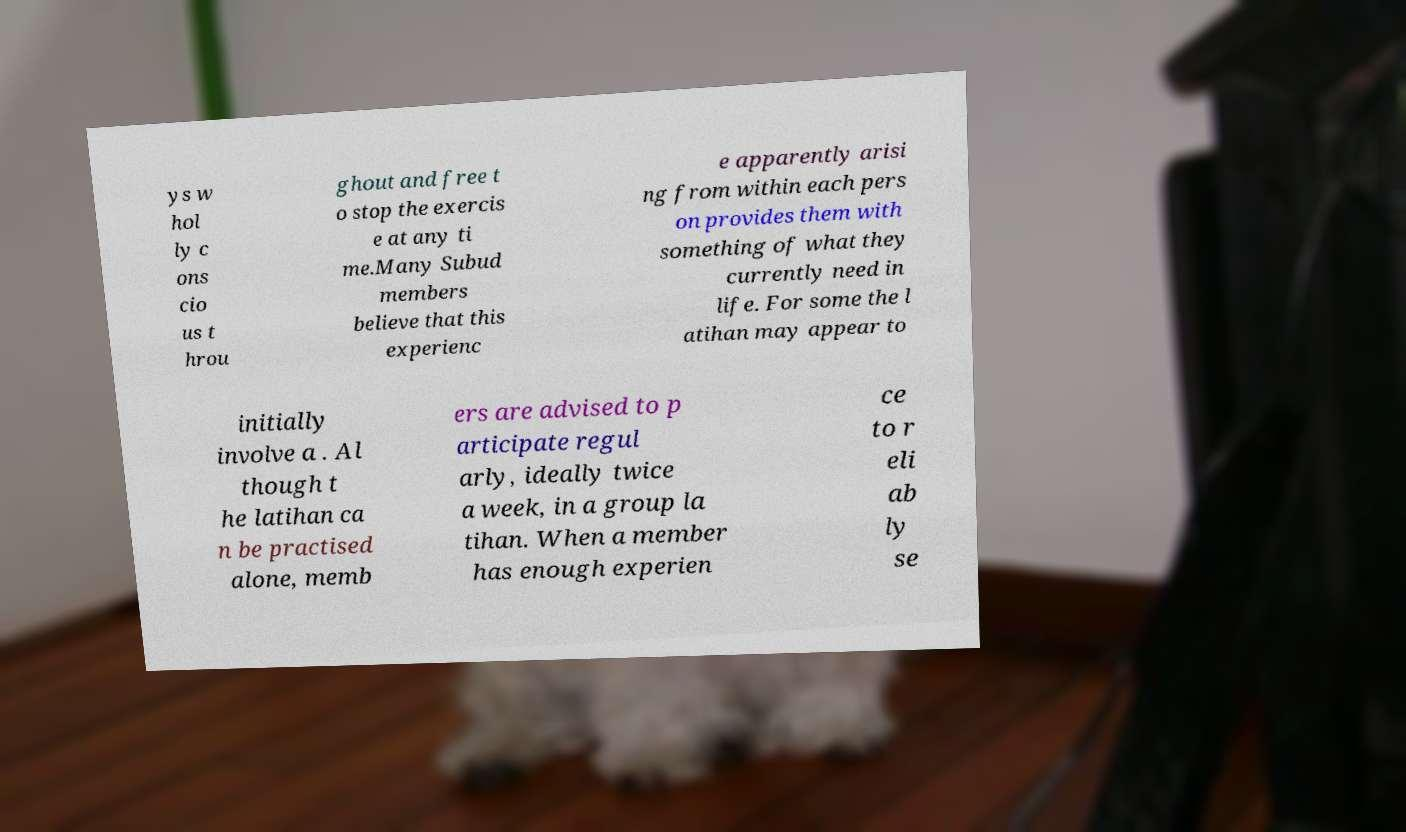Please identify and transcribe the text found in this image. ys w hol ly c ons cio us t hrou ghout and free t o stop the exercis e at any ti me.Many Subud members believe that this experienc e apparently arisi ng from within each pers on provides them with something of what they currently need in life. For some the l atihan may appear to initially involve a . Al though t he latihan ca n be practised alone, memb ers are advised to p articipate regul arly, ideally twice a week, in a group la tihan. When a member has enough experien ce to r eli ab ly se 